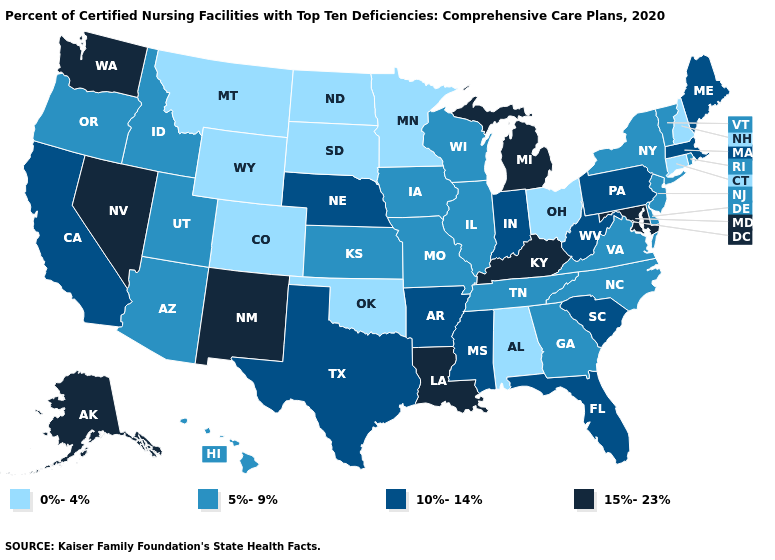Name the states that have a value in the range 15%-23%?
Concise answer only. Alaska, Kentucky, Louisiana, Maryland, Michigan, Nevada, New Mexico, Washington. What is the lowest value in states that border Minnesota?
Answer briefly. 0%-4%. What is the value of Colorado?
Keep it brief. 0%-4%. Name the states that have a value in the range 10%-14%?
Concise answer only. Arkansas, California, Florida, Indiana, Maine, Massachusetts, Mississippi, Nebraska, Pennsylvania, South Carolina, Texas, West Virginia. Is the legend a continuous bar?
Write a very short answer. No. What is the lowest value in the Northeast?
Be succinct. 0%-4%. Does Florida have the highest value in the South?
Answer briefly. No. Does the map have missing data?
Concise answer only. No. Does Oklahoma have a higher value than New Jersey?
Be succinct. No. Does Vermont have the lowest value in the Northeast?
Answer briefly. No. Name the states that have a value in the range 5%-9%?
Answer briefly. Arizona, Delaware, Georgia, Hawaii, Idaho, Illinois, Iowa, Kansas, Missouri, New Jersey, New York, North Carolina, Oregon, Rhode Island, Tennessee, Utah, Vermont, Virginia, Wisconsin. What is the value of Minnesota?
Short answer required. 0%-4%. How many symbols are there in the legend?
Be succinct. 4. Does Maine have the highest value in the Northeast?
Write a very short answer. Yes. What is the lowest value in the USA?
Keep it brief. 0%-4%. 